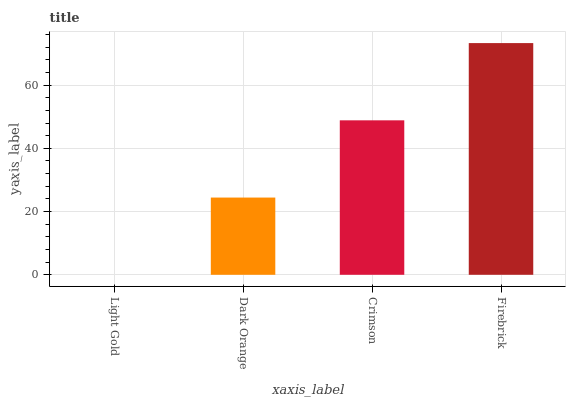Is Light Gold the minimum?
Answer yes or no. Yes. Is Firebrick the maximum?
Answer yes or no. Yes. Is Dark Orange the minimum?
Answer yes or no. No. Is Dark Orange the maximum?
Answer yes or no. No. Is Dark Orange greater than Light Gold?
Answer yes or no. Yes. Is Light Gold less than Dark Orange?
Answer yes or no. Yes. Is Light Gold greater than Dark Orange?
Answer yes or no. No. Is Dark Orange less than Light Gold?
Answer yes or no. No. Is Crimson the high median?
Answer yes or no. Yes. Is Dark Orange the low median?
Answer yes or no. Yes. Is Firebrick the high median?
Answer yes or no. No. Is Light Gold the low median?
Answer yes or no. No. 